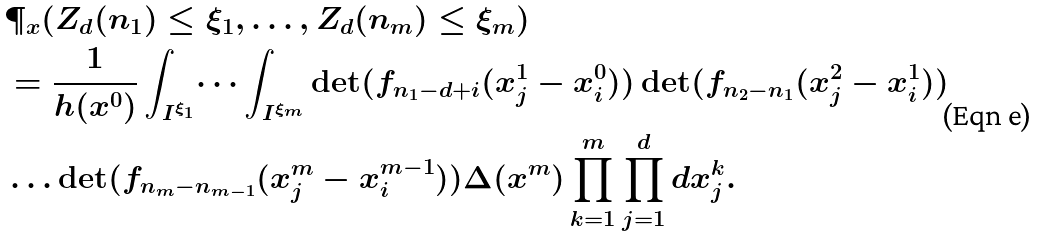Convert formula to latex. <formula><loc_0><loc_0><loc_500><loc_500>& \P _ { x } ( Z _ { d } ( n _ { 1 } ) \leq \xi _ { 1 } , \dots , Z _ { d } ( n _ { m } ) \leq \xi _ { m } ) \\ & = \frac { 1 } { h ( x ^ { 0 } ) } \int _ { I ^ { \xi _ { 1 } } } \dots \int _ { I ^ { \xi _ { m } } } \det ( f _ { n _ { 1 } - d + i } ( x _ { j } ^ { 1 } - x _ { i } ^ { 0 } ) ) \det ( f _ { n _ { 2 } - n _ { 1 } } ( x _ { j } ^ { 2 } - x _ { i } ^ { 1 } ) ) \\ & \dots \det ( f _ { n _ { m } - n _ { m - 1 } } ( x _ { j } ^ { m } - x _ { i } ^ { m - 1 } ) ) \Delta ( x ^ { m } ) \prod _ { k = 1 } ^ { m } \prod _ { j = 1 } ^ { d } d x _ { j } ^ { k } .</formula> 